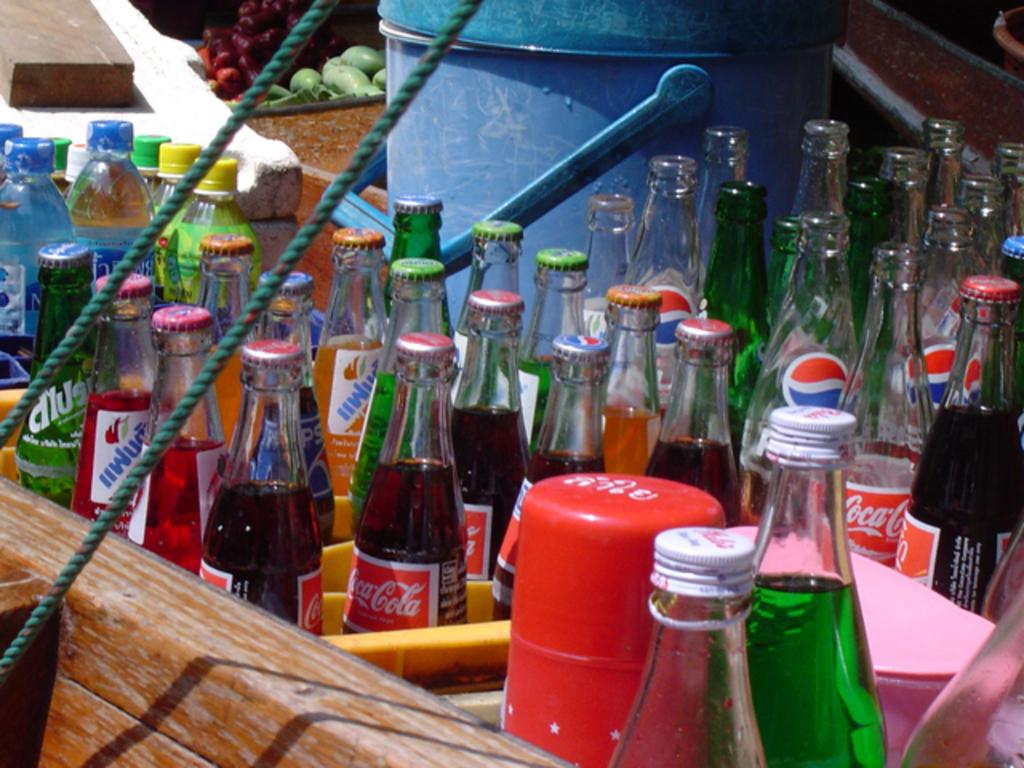<image>
Present a compact description of the photo's key features. A bunch of Coca-Cola glass bottles sitting among many other glass bottles. 